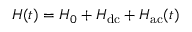Convert formula to latex. <formula><loc_0><loc_0><loc_500><loc_500>H ( t ) = H _ { 0 } + H _ { d c } + H _ { a c } ( t )</formula> 